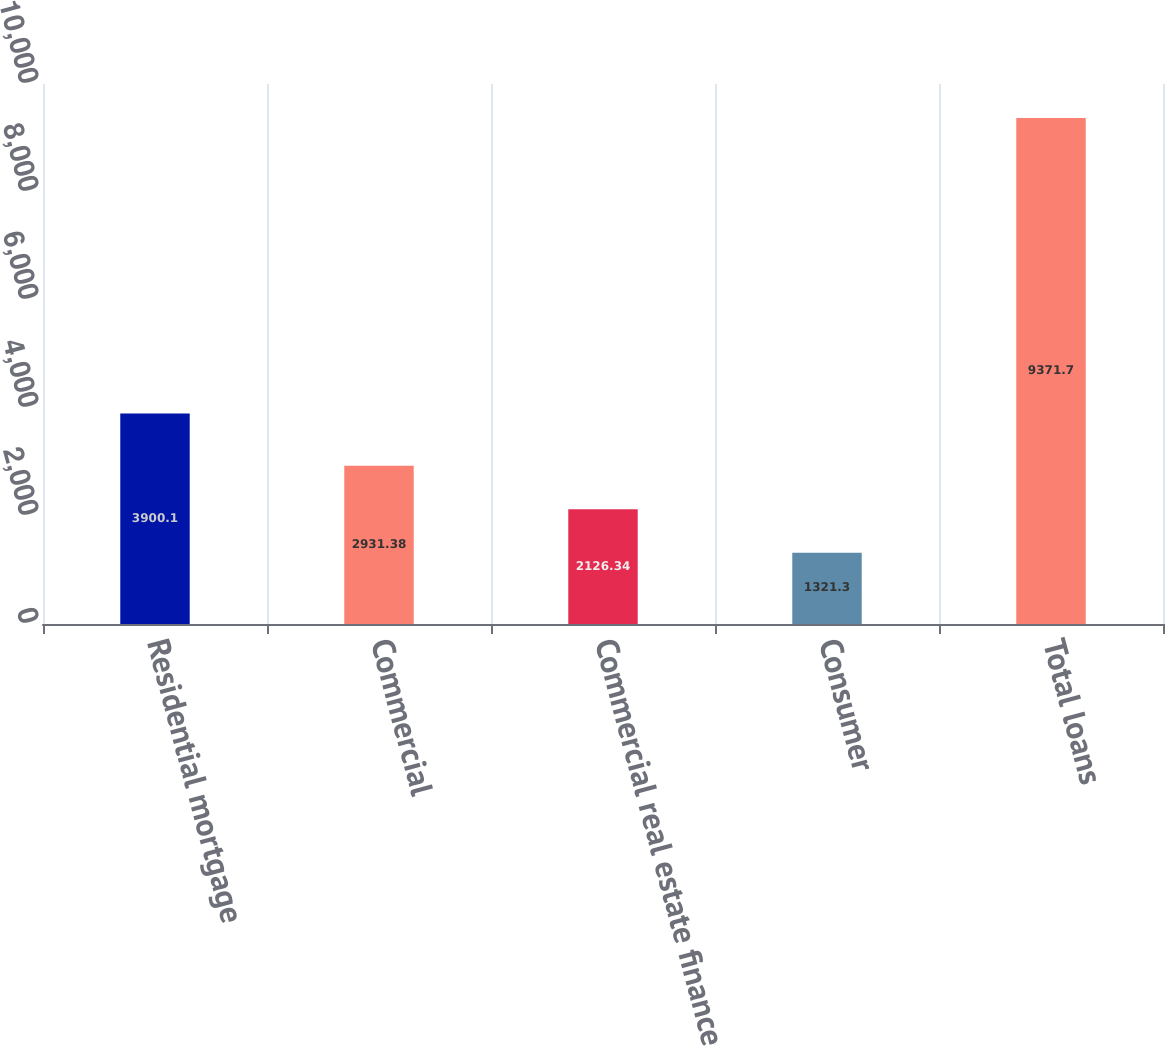Convert chart. <chart><loc_0><loc_0><loc_500><loc_500><bar_chart><fcel>Residential mortgage<fcel>Commercial<fcel>Commercial real estate finance<fcel>Consumer<fcel>Total loans<nl><fcel>3900.1<fcel>2931.38<fcel>2126.34<fcel>1321.3<fcel>9371.7<nl></chart> 